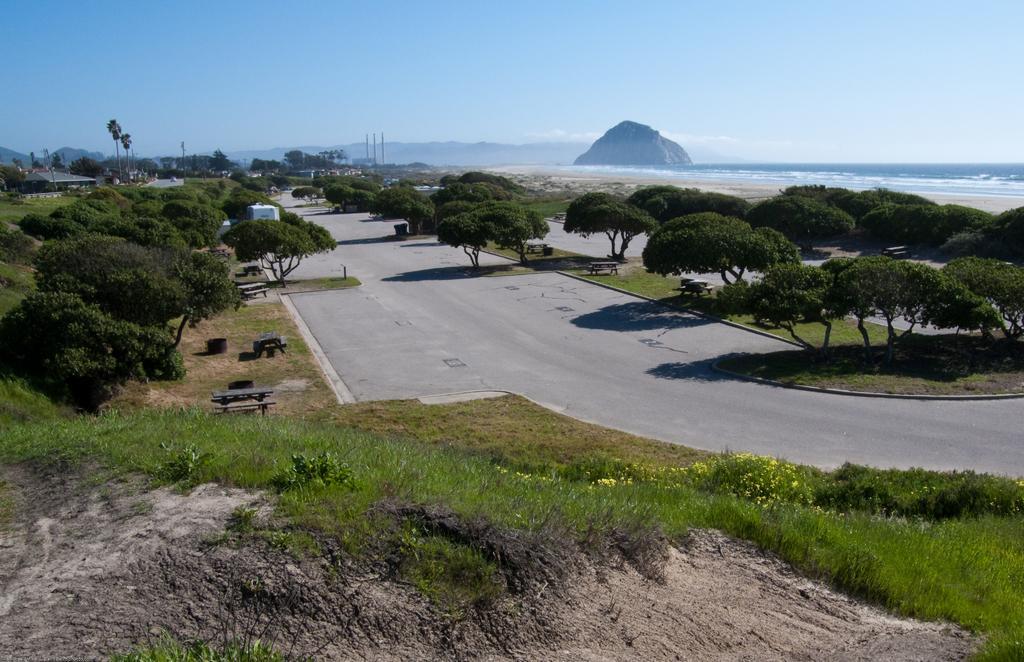In one or two sentences, can you explain what this image depicts? On the left side, there is dry land near grass on the ground. In the background, there is a road. On both sides of this road, there is grass and there are trees, there is another road, there is water, there are mountains and there is blue sky. 